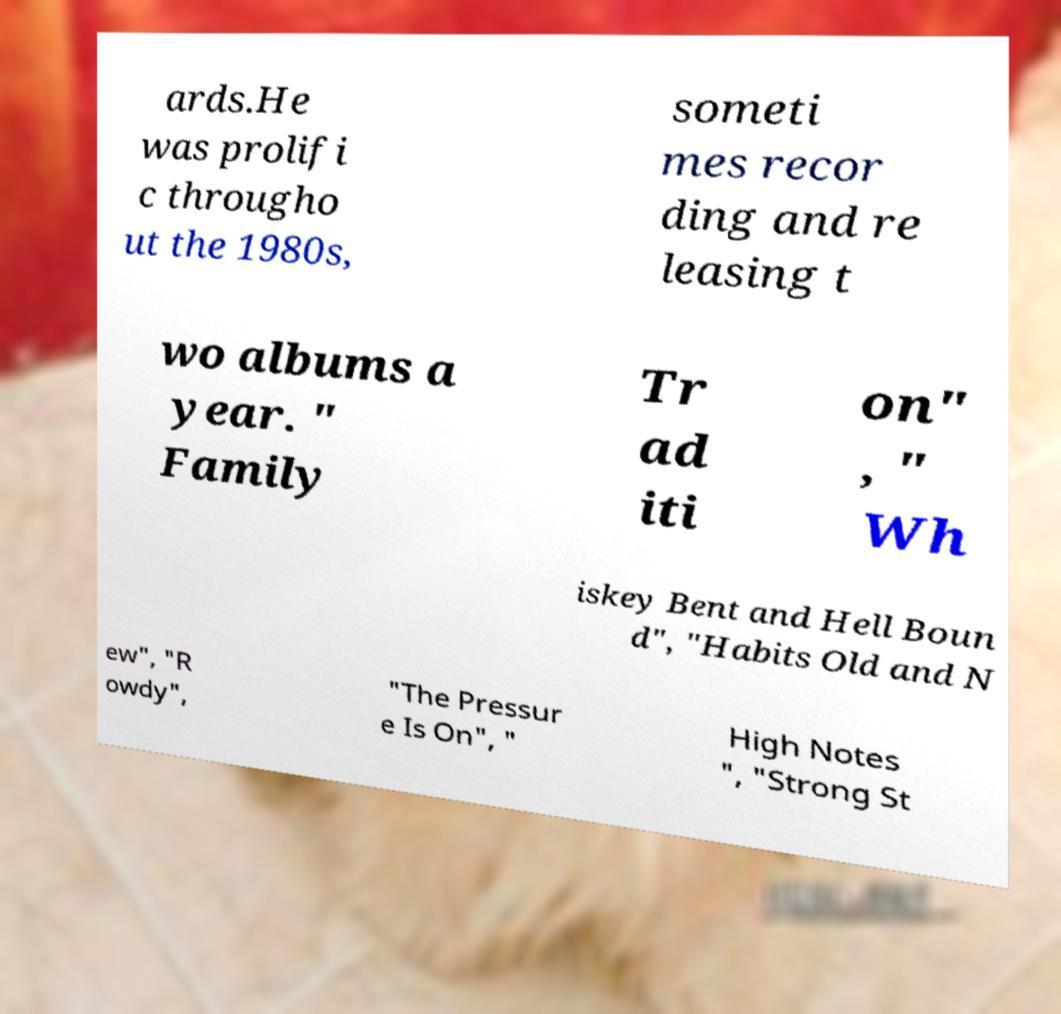What messages or text are displayed in this image? I need them in a readable, typed format. ards.He was prolifi c througho ut the 1980s, someti mes recor ding and re leasing t wo albums a year. " Family Tr ad iti on" , " Wh iskey Bent and Hell Boun d", "Habits Old and N ew", "R owdy", "The Pressur e Is On", " High Notes ", "Strong St 